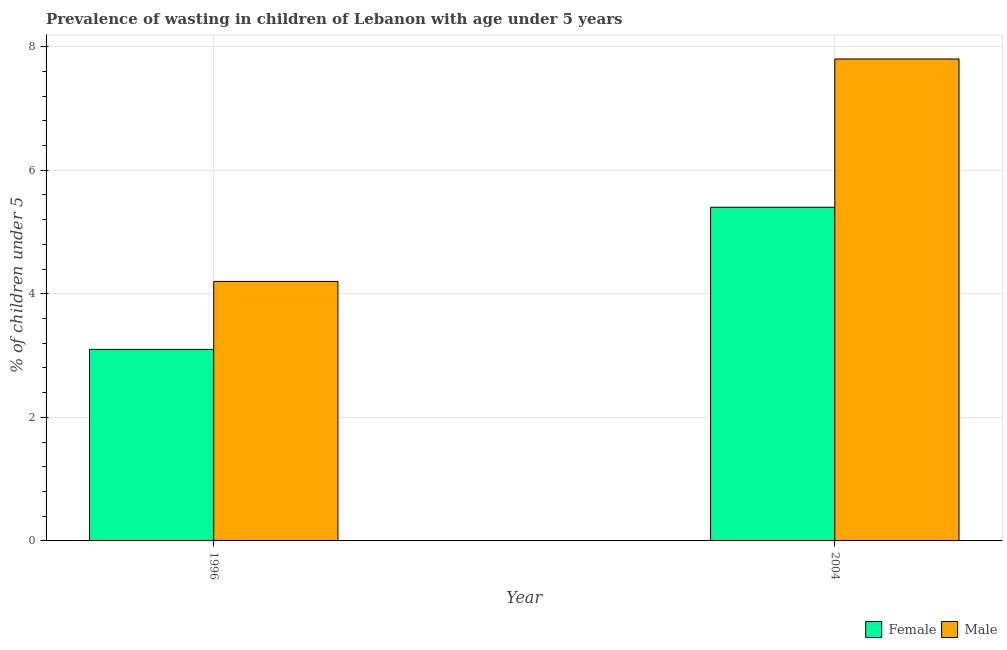How many different coloured bars are there?
Make the answer very short. 2. Are the number of bars per tick equal to the number of legend labels?
Ensure brevity in your answer.  Yes. How many bars are there on the 2nd tick from the right?
Offer a terse response. 2. What is the percentage of undernourished female children in 2004?
Ensure brevity in your answer.  5.4. Across all years, what is the maximum percentage of undernourished female children?
Offer a terse response. 5.4. Across all years, what is the minimum percentage of undernourished male children?
Your answer should be very brief. 4.2. In which year was the percentage of undernourished female children minimum?
Your answer should be very brief. 1996. What is the difference between the percentage of undernourished female children in 1996 and that in 2004?
Ensure brevity in your answer.  -2.3. What is the difference between the percentage of undernourished male children in 1996 and the percentage of undernourished female children in 2004?
Keep it short and to the point. -3.6. What is the average percentage of undernourished female children per year?
Ensure brevity in your answer.  4.25. What is the ratio of the percentage of undernourished male children in 1996 to that in 2004?
Make the answer very short. 0.54. Are all the bars in the graph horizontal?
Make the answer very short. No. What is the difference between two consecutive major ticks on the Y-axis?
Ensure brevity in your answer.  2. How many legend labels are there?
Offer a very short reply. 2. How are the legend labels stacked?
Offer a terse response. Horizontal. What is the title of the graph?
Provide a succinct answer. Prevalence of wasting in children of Lebanon with age under 5 years. What is the label or title of the X-axis?
Make the answer very short. Year. What is the label or title of the Y-axis?
Offer a terse response.  % of children under 5. What is the  % of children under 5 of Female in 1996?
Your response must be concise. 3.1. What is the  % of children under 5 in Male in 1996?
Your answer should be compact. 4.2. What is the  % of children under 5 in Female in 2004?
Your response must be concise. 5.4. What is the  % of children under 5 of Male in 2004?
Keep it short and to the point. 7.8. Across all years, what is the maximum  % of children under 5 of Female?
Your answer should be very brief. 5.4. Across all years, what is the maximum  % of children under 5 in Male?
Your response must be concise. 7.8. Across all years, what is the minimum  % of children under 5 of Female?
Your answer should be compact. 3.1. Across all years, what is the minimum  % of children under 5 of Male?
Make the answer very short. 4.2. What is the total  % of children under 5 in Male in the graph?
Ensure brevity in your answer.  12. What is the average  % of children under 5 of Female per year?
Your answer should be compact. 4.25. What is the average  % of children under 5 in Male per year?
Keep it short and to the point. 6. In the year 2004, what is the difference between the  % of children under 5 in Female and  % of children under 5 in Male?
Make the answer very short. -2.4. What is the ratio of the  % of children under 5 of Female in 1996 to that in 2004?
Ensure brevity in your answer.  0.57. What is the ratio of the  % of children under 5 in Male in 1996 to that in 2004?
Give a very brief answer. 0.54. What is the difference between the highest and the second highest  % of children under 5 in Female?
Offer a very short reply. 2.3. What is the difference between the highest and the second highest  % of children under 5 of Male?
Offer a terse response. 3.6. 